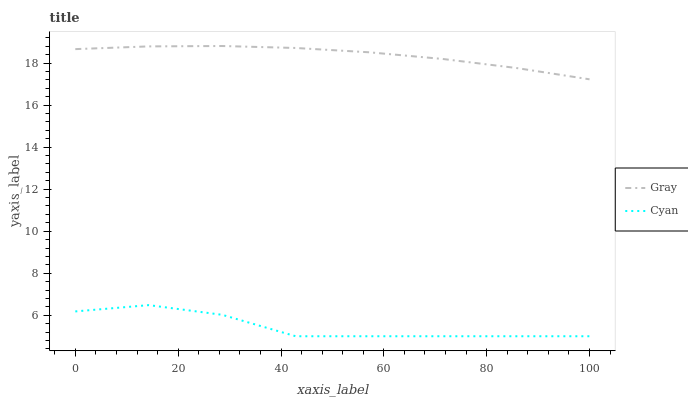Does Cyan have the maximum area under the curve?
Answer yes or no. No. Is Cyan the smoothest?
Answer yes or no. No. Does Cyan have the highest value?
Answer yes or no. No. Is Cyan less than Gray?
Answer yes or no. Yes. Is Gray greater than Cyan?
Answer yes or no. Yes. Does Cyan intersect Gray?
Answer yes or no. No. 